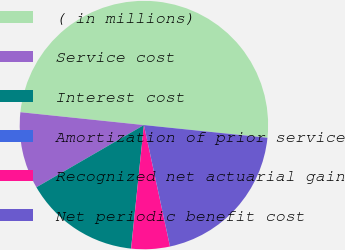<chart> <loc_0><loc_0><loc_500><loc_500><pie_chart><fcel>( in millions)<fcel>Service cost<fcel>Interest cost<fcel>Amortization of prior service<fcel>Recognized net actuarial gain<fcel>Net periodic benefit cost<nl><fcel>49.98%<fcel>10.0%<fcel>15.0%<fcel>0.01%<fcel>5.01%<fcel>20.0%<nl></chart> 